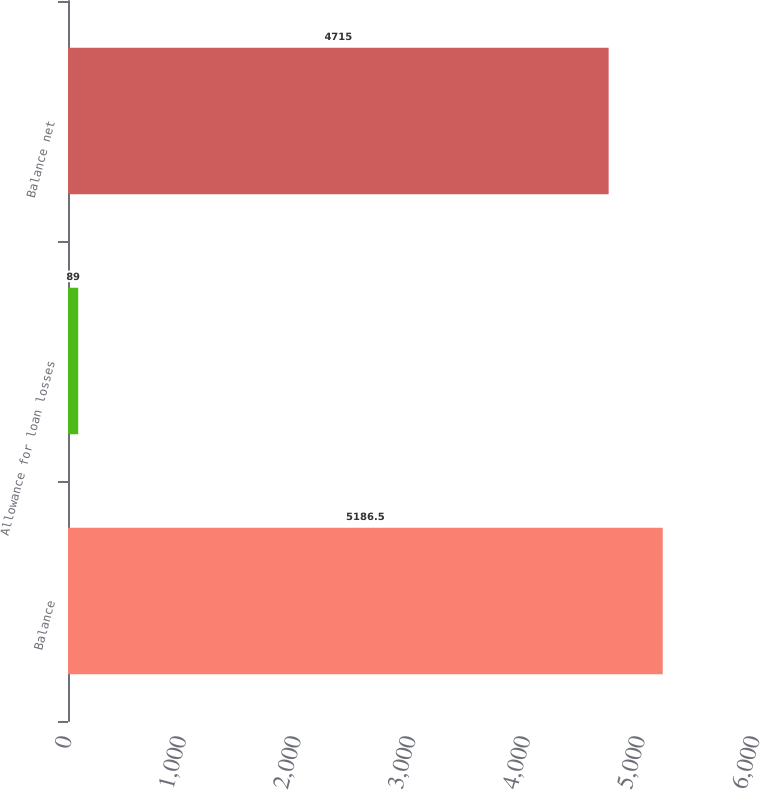Convert chart. <chart><loc_0><loc_0><loc_500><loc_500><bar_chart><fcel>Balance<fcel>Allowance for loan losses<fcel>Balance net<nl><fcel>5186.5<fcel>89<fcel>4715<nl></chart> 